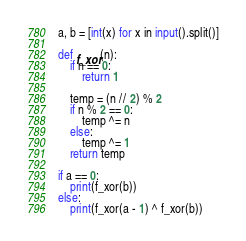Convert code to text. <code><loc_0><loc_0><loc_500><loc_500><_Python_>a, b = [int(x) for x in input().split()]

def f_xor(n):
    if n == 0:
        return 1
    
    temp = (n // 2) % 2
    if n % 2 == 0:
        temp ^= n
    else:
        temp ^= 1
    return temp

if a == 0:
    print(f_xor(b))
else:
    print(f_xor(a - 1) ^ f_xor(b))</code> 